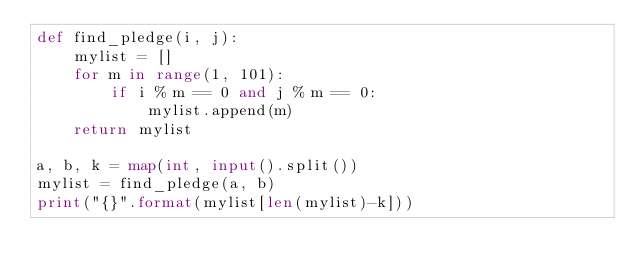Convert code to text. <code><loc_0><loc_0><loc_500><loc_500><_Python_>def find_pledge(i, j):
    mylist = []
    for m in range(1, 101):
        if i % m == 0 and j % m == 0:
            mylist.append(m)
    return mylist

a, b, k = map(int, input().split())
mylist = find_pledge(a, b)
print("{}".format(mylist[len(mylist)-k]))</code> 